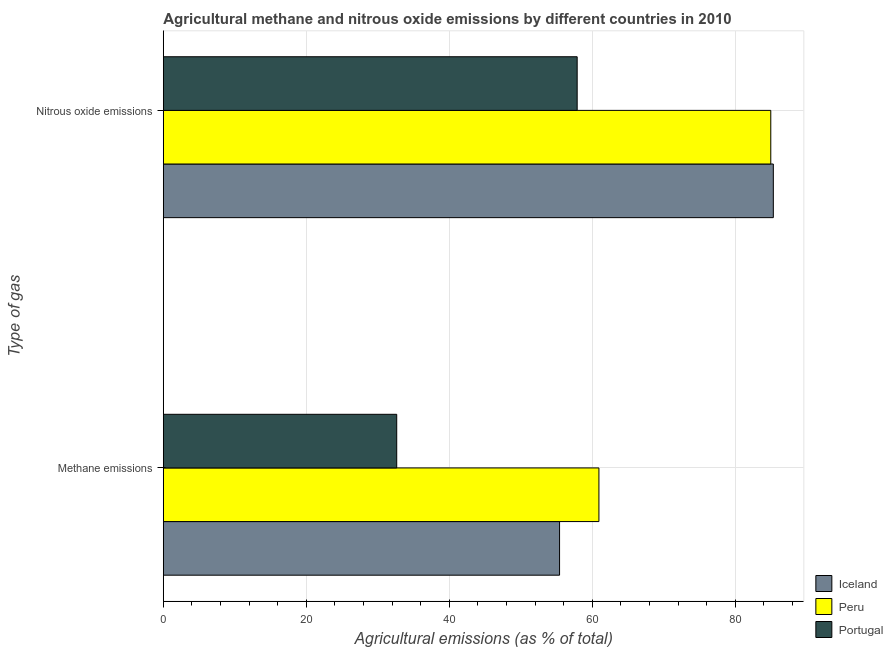How many groups of bars are there?
Provide a succinct answer. 2. How many bars are there on the 2nd tick from the top?
Keep it short and to the point. 3. What is the label of the 2nd group of bars from the top?
Keep it short and to the point. Methane emissions. What is the amount of nitrous oxide emissions in Peru?
Your answer should be compact. 84.95. Across all countries, what is the maximum amount of nitrous oxide emissions?
Offer a terse response. 85.31. Across all countries, what is the minimum amount of nitrous oxide emissions?
Ensure brevity in your answer.  57.88. In which country was the amount of methane emissions maximum?
Make the answer very short. Peru. What is the total amount of nitrous oxide emissions in the graph?
Your answer should be compact. 228.14. What is the difference between the amount of nitrous oxide emissions in Peru and that in Portugal?
Make the answer very short. 27.07. What is the difference between the amount of nitrous oxide emissions in Iceland and the amount of methane emissions in Peru?
Your response must be concise. 24.39. What is the average amount of methane emissions per country?
Your answer should be very brief. 49.66. What is the difference between the amount of nitrous oxide emissions and amount of methane emissions in Portugal?
Offer a very short reply. 25.23. In how many countries, is the amount of methane emissions greater than 36 %?
Give a very brief answer. 2. What is the ratio of the amount of methane emissions in Portugal to that in Iceland?
Give a very brief answer. 0.59. What does the 3rd bar from the top in Nitrous oxide emissions represents?
Make the answer very short. Iceland. How many bars are there?
Ensure brevity in your answer.  6. Are all the bars in the graph horizontal?
Ensure brevity in your answer.  Yes. How many countries are there in the graph?
Give a very brief answer. 3. Does the graph contain any zero values?
Provide a short and direct response. No. Where does the legend appear in the graph?
Make the answer very short. Bottom right. How are the legend labels stacked?
Your response must be concise. Vertical. What is the title of the graph?
Make the answer very short. Agricultural methane and nitrous oxide emissions by different countries in 2010. Does "Tajikistan" appear as one of the legend labels in the graph?
Provide a short and direct response. No. What is the label or title of the X-axis?
Ensure brevity in your answer.  Agricultural emissions (as % of total). What is the label or title of the Y-axis?
Make the answer very short. Type of gas. What is the Agricultural emissions (as % of total) of Iceland in Methane emissions?
Give a very brief answer. 55.41. What is the Agricultural emissions (as % of total) in Peru in Methane emissions?
Provide a succinct answer. 60.92. What is the Agricultural emissions (as % of total) of Portugal in Methane emissions?
Provide a short and direct response. 32.64. What is the Agricultural emissions (as % of total) of Iceland in Nitrous oxide emissions?
Keep it short and to the point. 85.31. What is the Agricultural emissions (as % of total) of Peru in Nitrous oxide emissions?
Offer a terse response. 84.95. What is the Agricultural emissions (as % of total) of Portugal in Nitrous oxide emissions?
Make the answer very short. 57.88. Across all Type of gas, what is the maximum Agricultural emissions (as % of total) of Iceland?
Provide a succinct answer. 85.31. Across all Type of gas, what is the maximum Agricultural emissions (as % of total) in Peru?
Offer a very short reply. 84.95. Across all Type of gas, what is the maximum Agricultural emissions (as % of total) in Portugal?
Make the answer very short. 57.88. Across all Type of gas, what is the minimum Agricultural emissions (as % of total) in Iceland?
Offer a very short reply. 55.41. Across all Type of gas, what is the minimum Agricultural emissions (as % of total) of Peru?
Offer a terse response. 60.92. Across all Type of gas, what is the minimum Agricultural emissions (as % of total) of Portugal?
Ensure brevity in your answer.  32.64. What is the total Agricultural emissions (as % of total) of Iceland in the graph?
Offer a terse response. 140.72. What is the total Agricultural emissions (as % of total) of Peru in the graph?
Your answer should be compact. 145.87. What is the total Agricultural emissions (as % of total) in Portugal in the graph?
Give a very brief answer. 90.52. What is the difference between the Agricultural emissions (as % of total) of Iceland in Methane emissions and that in Nitrous oxide emissions?
Ensure brevity in your answer.  -29.89. What is the difference between the Agricultural emissions (as % of total) in Peru in Methane emissions and that in Nitrous oxide emissions?
Keep it short and to the point. -24.03. What is the difference between the Agricultural emissions (as % of total) of Portugal in Methane emissions and that in Nitrous oxide emissions?
Offer a very short reply. -25.23. What is the difference between the Agricultural emissions (as % of total) in Iceland in Methane emissions and the Agricultural emissions (as % of total) in Peru in Nitrous oxide emissions?
Provide a succinct answer. -29.54. What is the difference between the Agricultural emissions (as % of total) in Iceland in Methane emissions and the Agricultural emissions (as % of total) in Portugal in Nitrous oxide emissions?
Offer a very short reply. -2.46. What is the difference between the Agricultural emissions (as % of total) in Peru in Methane emissions and the Agricultural emissions (as % of total) in Portugal in Nitrous oxide emissions?
Make the answer very short. 3.04. What is the average Agricultural emissions (as % of total) of Iceland per Type of gas?
Ensure brevity in your answer.  70.36. What is the average Agricultural emissions (as % of total) of Peru per Type of gas?
Your answer should be compact. 72.93. What is the average Agricultural emissions (as % of total) in Portugal per Type of gas?
Keep it short and to the point. 45.26. What is the difference between the Agricultural emissions (as % of total) of Iceland and Agricultural emissions (as % of total) of Peru in Methane emissions?
Make the answer very short. -5.5. What is the difference between the Agricultural emissions (as % of total) of Iceland and Agricultural emissions (as % of total) of Portugal in Methane emissions?
Ensure brevity in your answer.  22.77. What is the difference between the Agricultural emissions (as % of total) of Peru and Agricultural emissions (as % of total) of Portugal in Methane emissions?
Your answer should be very brief. 28.27. What is the difference between the Agricultural emissions (as % of total) in Iceland and Agricultural emissions (as % of total) in Peru in Nitrous oxide emissions?
Provide a succinct answer. 0.36. What is the difference between the Agricultural emissions (as % of total) in Iceland and Agricultural emissions (as % of total) in Portugal in Nitrous oxide emissions?
Offer a very short reply. 27.43. What is the difference between the Agricultural emissions (as % of total) in Peru and Agricultural emissions (as % of total) in Portugal in Nitrous oxide emissions?
Give a very brief answer. 27.07. What is the ratio of the Agricultural emissions (as % of total) of Iceland in Methane emissions to that in Nitrous oxide emissions?
Provide a succinct answer. 0.65. What is the ratio of the Agricultural emissions (as % of total) of Peru in Methane emissions to that in Nitrous oxide emissions?
Provide a succinct answer. 0.72. What is the ratio of the Agricultural emissions (as % of total) of Portugal in Methane emissions to that in Nitrous oxide emissions?
Offer a terse response. 0.56. What is the difference between the highest and the second highest Agricultural emissions (as % of total) of Iceland?
Give a very brief answer. 29.89. What is the difference between the highest and the second highest Agricultural emissions (as % of total) of Peru?
Offer a terse response. 24.03. What is the difference between the highest and the second highest Agricultural emissions (as % of total) of Portugal?
Your response must be concise. 25.23. What is the difference between the highest and the lowest Agricultural emissions (as % of total) in Iceland?
Keep it short and to the point. 29.89. What is the difference between the highest and the lowest Agricultural emissions (as % of total) in Peru?
Make the answer very short. 24.03. What is the difference between the highest and the lowest Agricultural emissions (as % of total) of Portugal?
Keep it short and to the point. 25.23. 